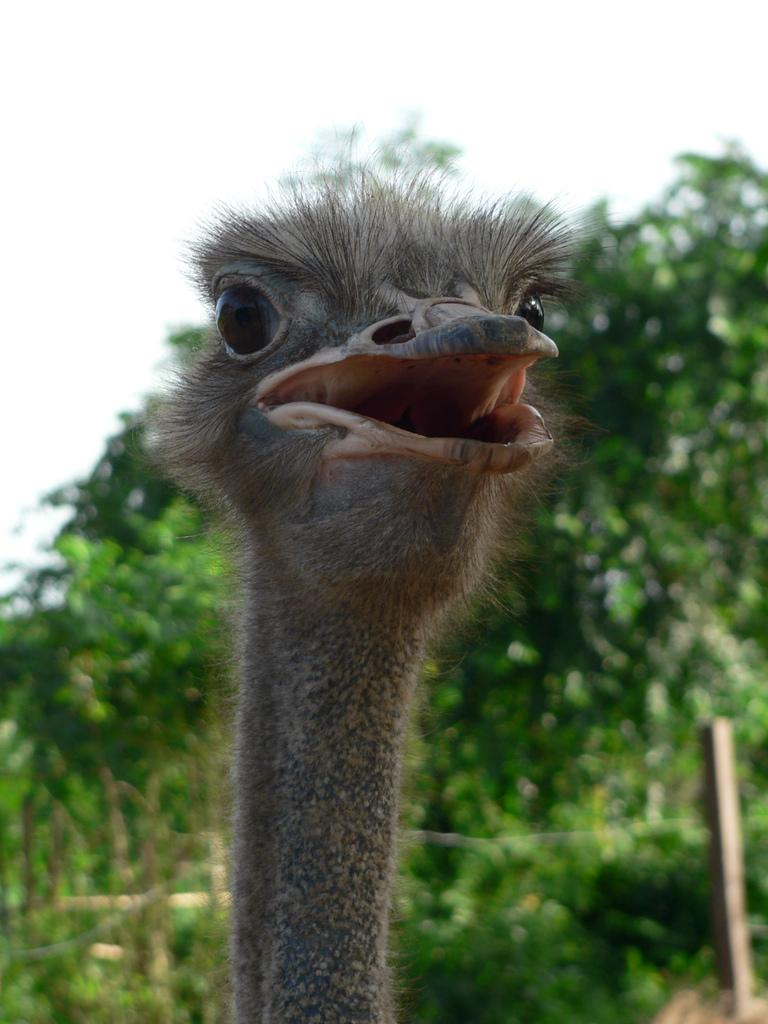What type of animal is in the image? There is an ostrich in the image. What other object can be seen in the image? There is a tree in the image. What is the long, vertical object in the image? There is a pole in the image. What is visible in the background of the image? The sky is visible in the image. What type of wood is the crook made of in the image? There is no crook present in the image, so it is not possible to determine what type of wood it might be made of. 